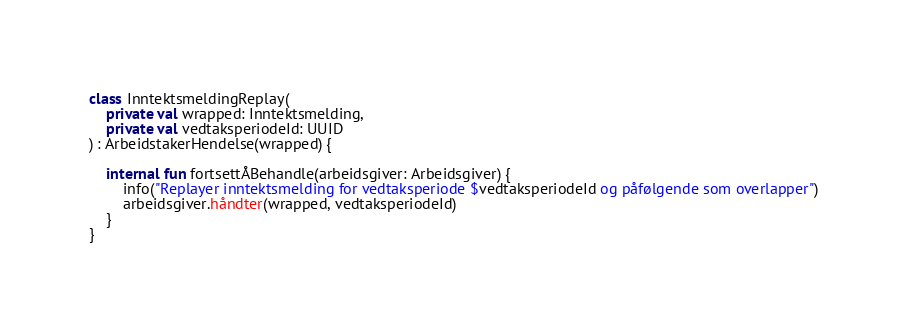<code> <loc_0><loc_0><loc_500><loc_500><_Kotlin_>class InntektsmeldingReplay(
    private val wrapped: Inntektsmelding,
    private val vedtaksperiodeId: UUID
) : ArbeidstakerHendelse(wrapped) {

    internal fun fortsettÅBehandle(arbeidsgiver: Arbeidsgiver) {
        info("Replayer inntektsmelding for vedtaksperiode $vedtaksperiodeId og påfølgende som overlapper")
        arbeidsgiver.håndter(wrapped, vedtaksperiodeId)
    }
}
</code> 